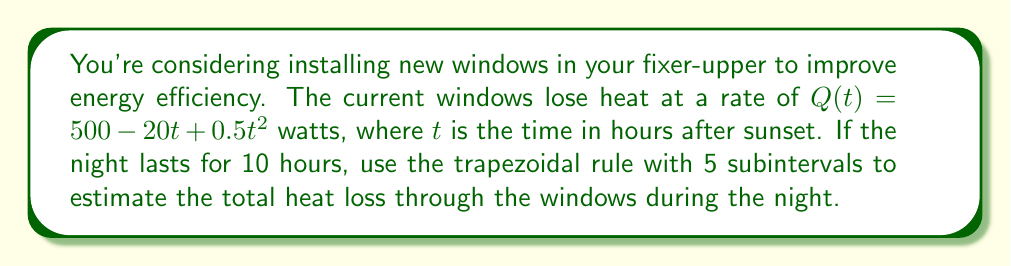Give your solution to this math problem. To solve this problem using the trapezoidal rule with 5 subintervals, we'll follow these steps:

1) The trapezoidal rule formula for n subintervals is:

   $$\int_{a}^{b} f(x) dx \approx \frac{h}{2}\left[f(x_0) + 2\sum_{i=1}^{n-1}f(x_i) + f(x_n)\right]$$

   where $h = \frac{b-a}{n}$, and $x_i = a + ih$ for $i = 0, 1, ..., n$

2) In our case:
   $a = 0$, $b = 10$, $n = 5$, so $h = \frac{10-0}{5} = 2$

3) Calculate the $x_i$ values:
   $x_0 = 0$, $x_1 = 2$, $x_2 = 4$, $x_3 = 6$, $x_4 = 8$, $x_5 = 10$

4) Calculate $Q(t)$ for each $x_i$:
   $Q(0) = 500 - 20(0) + 0.5(0)^2 = 500$
   $Q(2) = 500 - 20(2) + 0.5(2)^2 = 462$
   $Q(4) = 500 - 20(4) + 0.5(4)^2 = 428$
   $Q(6) = 500 - 20(6) + 0.5(6)^2 = 398$
   $Q(8) = 500 - 20(8) + 0.5(8)^2 = 372$
   $Q(10) = 500 - 20(10) + 0.5(10)^2 = 350$

5) Apply the trapezoidal rule:

   $$\int_{0}^{10} Q(t) dt \approx \frac{2}{2}[500 + 2(462 + 428 + 398 + 372) + 350]$$
   $$= 1[500 + 2(1660) + 350]$$
   $$= 1[500 + 3320 + 350]$$
   $$= 4170$$

6) The result is in watt-hours, which we need to convert to kilowatt-hours:
   $4170 \text{ Wh} = 4.17 \text{ kWh}$
Answer: 4.17 kWh 